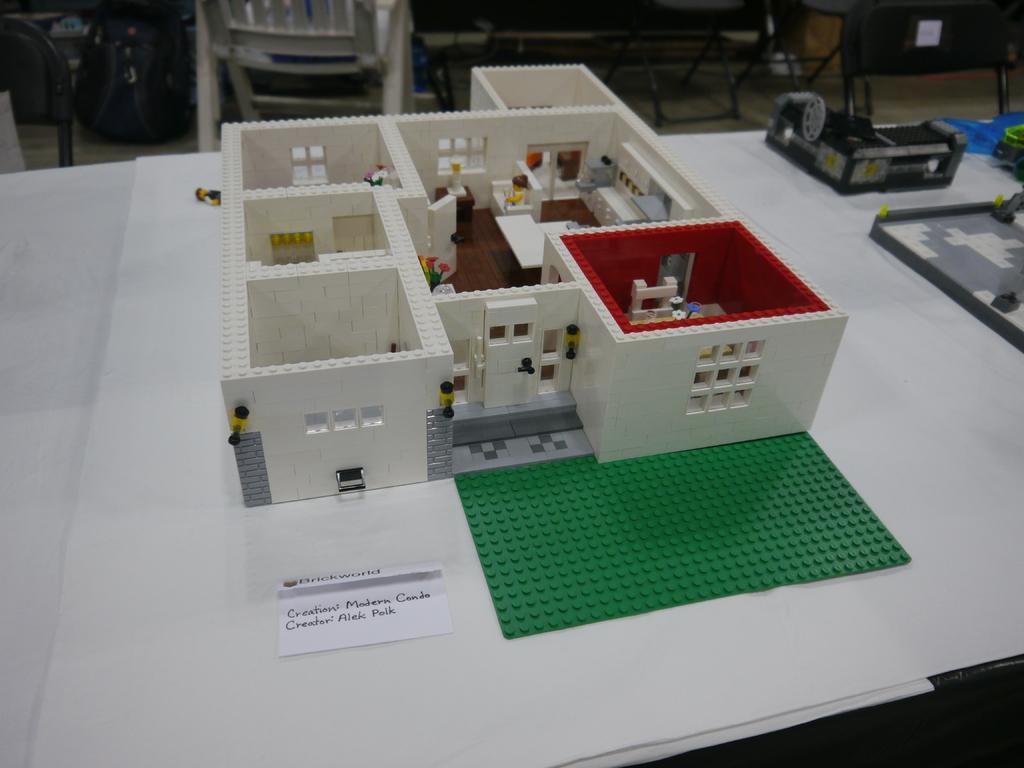In one or two sentences, can you explain what this image depicts? In this picture I can see there is a house, it has a door and windows and there are different rooms like hall, kitchen, bedroom and there is a doll here sitting on the sofa. This house is built with toys and it is placed on the table. There is something written on the paper here and in the backdrop there is a chair and tables. 